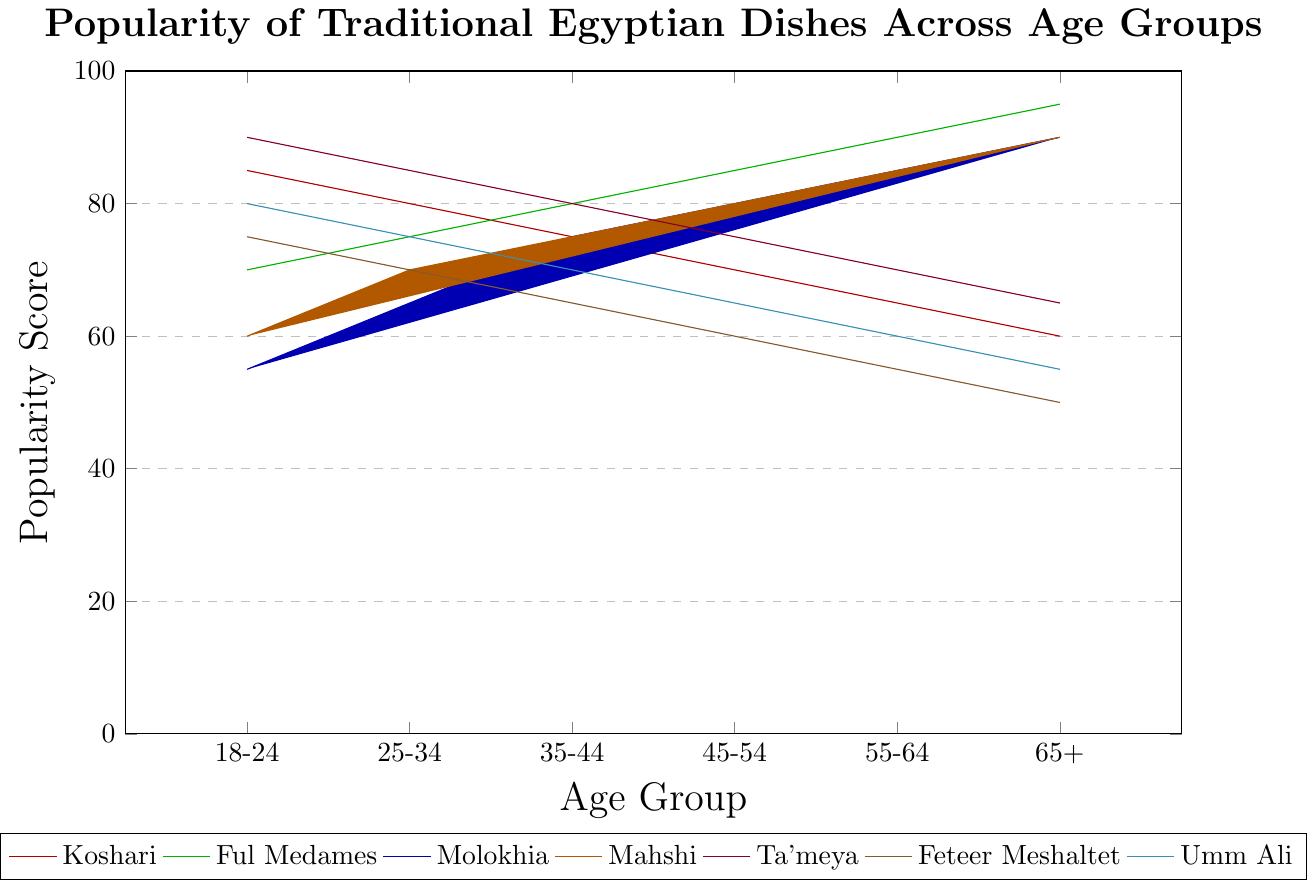What's the most popular dish among the age group 18-24? By observing the height of bars for each dish, the tallest bar in the age group 18-24 corresponds to Ta'meya.
Answer: Ta'meya Which dish shows a consistent increase in popularity as age increases? By examining each dish's bar heights across different age groups, Ful Medames consistently shows an increasing trend from 18-24 to 65+.
Answer: Ful Medames How does the popularity of Mahshi compare between the age groups 35-44 and 55-64? By comparing the bars for Mahshi in both age groups, we see that the value for 35-44 is 75, and for 55-64 is 85. Therefore, Mahshi is more popular in the age group 55-64.
Answer: Mahshi is more popular in the age group 55-64 What is the average popularity score of Ta'meya across all age groups? The scores for Ta'meya are 90, 85, 80, 75, 70, and 65. Adding these gives 465, and dividing by 6 age groups, the average is 465/6 = 77.5.
Answer: 77.5 Which dish has the lowest popularity in the age group 65+? By looking at the bars for 65+ age group, Feteer Meshaltet has the lowest score at 50.
Answer: Feteer Meshaltet Is Molokhia more popular in the age group 45-54 or 55-64? Comparing the bars for Molokhia in these age groups, Molokhia has a score of 80 in 45-54 and 85 in 55-64, so it is more popular in 55-64.
Answer: 55-64 What is the total popularity score of Koshari for age groups 25-34 and 65+ combined? The popularity scores for Koshari in these age groups are 80 and 60. Adding these scores gives 80 + 60 = 140.
Answer: 140 Which dish has the largest drop in popularity from age group 18-24 to 65+? By comparing the popularity scores across all the dishes, Koshari drops from 85 in 18-24 to 60 in 65+, resulting in the largest drop of 25 points.
Answer: Koshari What is the median popularity score of Umm Ali across all age groups? The popularity scores for Umm Ali are arranged as [55, 60, 65, 70, 75, 80]. The median is the average of the 3rd and 4th values, which is (65 + 70)/2 = 67.5.
Answer: 67.5 